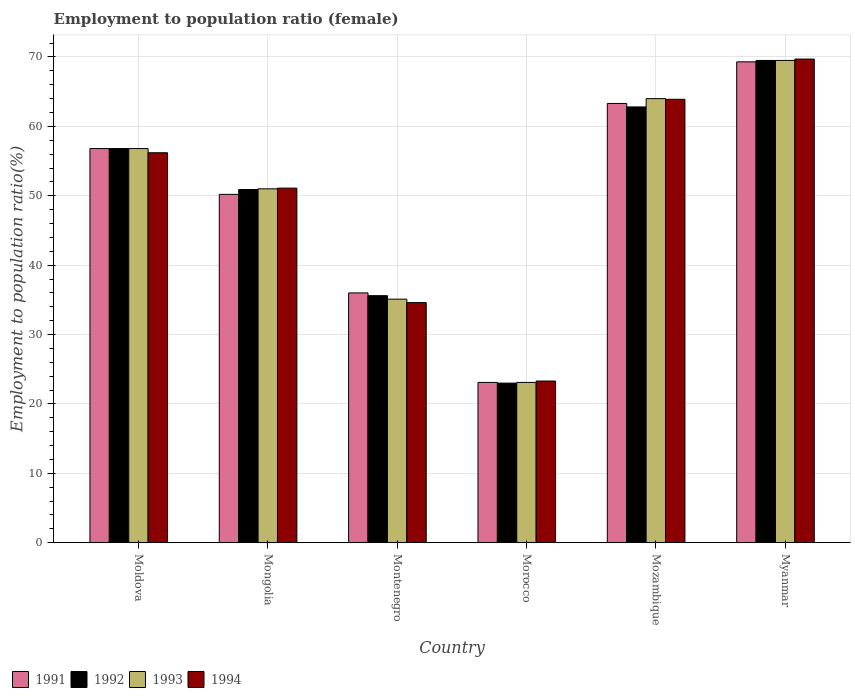How many different coloured bars are there?
Ensure brevity in your answer.  4. Are the number of bars per tick equal to the number of legend labels?
Your answer should be very brief. Yes. Are the number of bars on each tick of the X-axis equal?
Offer a terse response. Yes. What is the label of the 3rd group of bars from the left?
Ensure brevity in your answer.  Montenegro. What is the employment to population ratio in 1992 in Mongolia?
Ensure brevity in your answer.  50.9. Across all countries, what is the maximum employment to population ratio in 1993?
Provide a succinct answer. 69.5. Across all countries, what is the minimum employment to population ratio in 1991?
Make the answer very short. 23.1. In which country was the employment to population ratio in 1994 maximum?
Give a very brief answer. Myanmar. In which country was the employment to population ratio in 1993 minimum?
Ensure brevity in your answer.  Morocco. What is the total employment to population ratio in 1994 in the graph?
Your answer should be very brief. 298.8. What is the difference between the employment to population ratio in 1992 in Moldova and that in Morocco?
Your answer should be very brief. 33.8. What is the difference between the employment to population ratio in 1992 in Mozambique and the employment to population ratio in 1994 in Myanmar?
Offer a very short reply. -6.9. What is the average employment to population ratio in 1991 per country?
Give a very brief answer. 49.78. What is the ratio of the employment to population ratio in 1994 in Mozambique to that in Myanmar?
Provide a succinct answer. 0.92. Is the employment to population ratio in 1993 in Montenegro less than that in Morocco?
Your response must be concise. No. Is the difference between the employment to population ratio in 1994 in Moldova and Montenegro greater than the difference between the employment to population ratio in 1993 in Moldova and Montenegro?
Give a very brief answer. No. What is the difference between the highest and the second highest employment to population ratio in 1994?
Offer a very short reply. -13.5. What is the difference between the highest and the lowest employment to population ratio in 1992?
Your response must be concise. 46.5. In how many countries, is the employment to population ratio in 1993 greater than the average employment to population ratio in 1993 taken over all countries?
Offer a very short reply. 4. Is it the case that in every country, the sum of the employment to population ratio in 1991 and employment to population ratio in 1993 is greater than the sum of employment to population ratio in 1992 and employment to population ratio in 1994?
Offer a terse response. No. How are the legend labels stacked?
Make the answer very short. Horizontal. What is the title of the graph?
Your response must be concise. Employment to population ratio (female). What is the label or title of the X-axis?
Keep it short and to the point. Country. What is the Employment to population ratio(%) in 1991 in Moldova?
Make the answer very short. 56.8. What is the Employment to population ratio(%) in 1992 in Moldova?
Offer a very short reply. 56.8. What is the Employment to population ratio(%) in 1993 in Moldova?
Ensure brevity in your answer.  56.8. What is the Employment to population ratio(%) of 1994 in Moldova?
Provide a short and direct response. 56.2. What is the Employment to population ratio(%) in 1991 in Mongolia?
Your answer should be compact. 50.2. What is the Employment to population ratio(%) in 1992 in Mongolia?
Ensure brevity in your answer.  50.9. What is the Employment to population ratio(%) in 1994 in Mongolia?
Provide a succinct answer. 51.1. What is the Employment to population ratio(%) of 1992 in Montenegro?
Offer a terse response. 35.6. What is the Employment to population ratio(%) in 1993 in Montenegro?
Make the answer very short. 35.1. What is the Employment to population ratio(%) in 1994 in Montenegro?
Your response must be concise. 34.6. What is the Employment to population ratio(%) of 1991 in Morocco?
Make the answer very short. 23.1. What is the Employment to population ratio(%) in 1992 in Morocco?
Give a very brief answer. 23. What is the Employment to population ratio(%) in 1993 in Morocco?
Your response must be concise. 23.1. What is the Employment to population ratio(%) of 1994 in Morocco?
Offer a terse response. 23.3. What is the Employment to population ratio(%) in 1991 in Mozambique?
Provide a short and direct response. 63.3. What is the Employment to population ratio(%) in 1992 in Mozambique?
Keep it short and to the point. 62.8. What is the Employment to population ratio(%) of 1993 in Mozambique?
Give a very brief answer. 64. What is the Employment to population ratio(%) in 1994 in Mozambique?
Keep it short and to the point. 63.9. What is the Employment to population ratio(%) of 1991 in Myanmar?
Provide a succinct answer. 69.3. What is the Employment to population ratio(%) in 1992 in Myanmar?
Ensure brevity in your answer.  69.5. What is the Employment to population ratio(%) of 1993 in Myanmar?
Your answer should be compact. 69.5. What is the Employment to population ratio(%) of 1994 in Myanmar?
Your answer should be very brief. 69.7. Across all countries, what is the maximum Employment to population ratio(%) in 1991?
Provide a succinct answer. 69.3. Across all countries, what is the maximum Employment to population ratio(%) of 1992?
Ensure brevity in your answer.  69.5. Across all countries, what is the maximum Employment to population ratio(%) in 1993?
Provide a succinct answer. 69.5. Across all countries, what is the maximum Employment to population ratio(%) in 1994?
Make the answer very short. 69.7. Across all countries, what is the minimum Employment to population ratio(%) in 1991?
Ensure brevity in your answer.  23.1. Across all countries, what is the minimum Employment to population ratio(%) of 1992?
Offer a terse response. 23. Across all countries, what is the minimum Employment to population ratio(%) in 1993?
Give a very brief answer. 23.1. Across all countries, what is the minimum Employment to population ratio(%) of 1994?
Make the answer very short. 23.3. What is the total Employment to population ratio(%) of 1991 in the graph?
Your answer should be very brief. 298.7. What is the total Employment to population ratio(%) in 1992 in the graph?
Ensure brevity in your answer.  298.6. What is the total Employment to population ratio(%) in 1993 in the graph?
Ensure brevity in your answer.  299.5. What is the total Employment to population ratio(%) of 1994 in the graph?
Provide a succinct answer. 298.8. What is the difference between the Employment to population ratio(%) in 1991 in Moldova and that in Mongolia?
Ensure brevity in your answer.  6.6. What is the difference between the Employment to population ratio(%) in 1992 in Moldova and that in Mongolia?
Your answer should be very brief. 5.9. What is the difference between the Employment to population ratio(%) of 1993 in Moldova and that in Mongolia?
Provide a short and direct response. 5.8. What is the difference between the Employment to population ratio(%) of 1991 in Moldova and that in Montenegro?
Give a very brief answer. 20.8. What is the difference between the Employment to population ratio(%) of 1992 in Moldova and that in Montenegro?
Offer a very short reply. 21.2. What is the difference between the Employment to population ratio(%) in 1993 in Moldova and that in Montenegro?
Offer a terse response. 21.7. What is the difference between the Employment to population ratio(%) of 1994 in Moldova and that in Montenegro?
Keep it short and to the point. 21.6. What is the difference between the Employment to population ratio(%) in 1991 in Moldova and that in Morocco?
Provide a succinct answer. 33.7. What is the difference between the Employment to population ratio(%) of 1992 in Moldova and that in Morocco?
Ensure brevity in your answer.  33.8. What is the difference between the Employment to population ratio(%) in 1993 in Moldova and that in Morocco?
Keep it short and to the point. 33.7. What is the difference between the Employment to population ratio(%) in 1994 in Moldova and that in Morocco?
Offer a terse response. 32.9. What is the difference between the Employment to population ratio(%) in 1992 in Moldova and that in Mozambique?
Make the answer very short. -6. What is the difference between the Employment to population ratio(%) of 1993 in Moldova and that in Mozambique?
Offer a terse response. -7.2. What is the difference between the Employment to population ratio(%) in 1994 in Moldova and that in Mozambique?
Keep it short and to the point. -7.7. What is the difference between the Employment to population ratio(%) of 1993 in Moldova and that in Myanmar?
Provide a succinct answer. -12.7. What is the difference between the Employment to population ratio(%) of 1994 in Moldova and that in Myanmar?
Provide a succinct answer. -13.5. What is the difference between the Employment to population ratio(%) in 1991 in Mongolia and that in Montenegro?
Ensure brevity in your answer.  14.2. What is the difference between the Employment to population ratio(%) of 1991 in Mongolia and that in Morocco?
Provide a succinct answer. 27.1. What is the difference between the Employment to population ratio(%) of 1992 in Mongolia and that in Morocco?
Your answer should be very brief. 27.9. What is the difference between the Employment to population ratio(%) of 1993 in Mongolia and that in Morocco?
Provide a short and direct response. 27.9. What is the difference between the Employment to population ratio(%) of 1994 in Mongolia and that in Morocco?
Ensure brevity in your answer.  27.8. What is the difference between the Employment to population ratio(%) in 1991 in Mongolia and that in Mozambique?
Offer a terse response. -13.1. What is the difference between the Employment to population ratio(%) in 1992 in Mongolia and that in Mozambique?
Your answer should be compact. -11.9. What is the difference between the Employment to population ratio(%) of 1994 in Mongolia and that in Mozambique?
Make the answer very short. -12.8. What is the difference between the Employment to population ratio(%) of 1991 in Mongolia and that in Myanmar?
Offer a very short reply. -19.1. What is the difference between the Employment to population ratio(%) of 1992 in Mongolia and that in Myanmar?
Provide a succinct answer. -18.6. What is the difference between the Employment to population ratio(%) in 1993 in Mongolia and that in Myanmar?
Your answer should be very brief. -18.5. What is the difference between the Employment to population ratio(%) of 1994 in Mongolia and that in Myanmar?
Provide a succinct answer. -18.6. What is the difference between the Employment to population ratio(%) in 1993 in Montenegro and that in Morocco?
Give a very brief answer. 12. What is the difference between the Employment to population ratio(%) in 1991 in Montenegro and that in Mozambique?
Make the answer very short. -27.3. What is the difference between the Employment to population ratio(%) of 1992 in Montenegro and that in Mozambique?
Your answer should be very brief. -27.2. What is the difference between the Employment to population ratio(%) of 1993 in Montenegro and that in Mozambique?
Offer a terse response. -28.9. What is the difference between the Employment to population ratio(%) of 1994 in Montenegro and that in Mozambique?
Your response must be concise. -29.3. What is the difference between the Employment to population ratio(%) of 1991 in Montenegro and that in Myanmar?
Make the answer very short. -33.3. What is the difference between the Employment to population ratio(%) in 1992 in Montenegro and that in Myanmar?
Your answer should be compact. -33.9. What is the difference between the Employment to population ratio(%) in 1993 in Montenegro and that in Myanmar?
Make the answer very short. -34.4. What is the difference between the Employment to population ratio(%) of 1994 in Montenegro and that in Myanmar?
Offer a terse response. -35.1. What is the difference between the Employment to population ratio(%) in 1991 in Morocco and that in Mozambique?
Your answer should be very brief. -40.2. What is the difference between the Employment to population ratio(%) of 1992 in Morocco and that in Mozambique?
Your answer should be very brief. -39.8. What is the difference between the Employment to population ratio(%) of 1993 in Morocco and that in Mozambique?
Keep it short and to the point. -40.9. What is the difference between the Employment to population ratio(%) of 1994 in Morocco and that in Mozambique?
Give a very brief answer. -40.6. What is the difference between the Employment to population ratio(%) in 1991 in Morocco and that in Myanmar?
Keep it short and to the point. -46.2. What is the difference between the Employment to population ratio(%) in 1992 in Morocco and that in Myanmar?
Offer a terse response. -46.5. What is the difference between the Employment to population ratio(%) in 1993 in Morocco and that in Myanmar?
Your response must be concise. -46.4. What is the difference between the Employment to population ratio(%) of 1994 in Morocco and that in Myanmar?
Provide a short and direct response. -46.4. What is the difference between the Employment to population ratio(%) in 1991 in Mozambique and that in Myanmar?
Your response must be concise. -6. What is the difference between the Employment to population ratio(%) in 1992 in Mozambique and that in Myanmar?
Keep it short and to the point. -6.7. What is the difference between the Employment to population ratio(%) in 1991 in Moldova and the Employment to population ratio(%) in 1992 in Mongolia?
Offer a terse response. 5.9. What is the difference between the Employment to population ratio(%) of 1991 in Moldova and the Employment to population ratio(%) of 1994 in Mongolia?
Offer a very short reply. 5.7. What is the difference between the Employment to population ratio(%) of 1993 in Moldova and the Employment to population ratio(%) of 1994 in Mongolia?
Give a very brief answer. 5.7. What is the difference between the Employment to population ratio(%) of 1991 in Moldova and the Employment to population ratio(%) of 1992 in Montenegro?
Offer a very short reply. 21.2. What is the difference between the Employment to population ratio(%) in 1991 in Moldova and the Employment to population ratio(%) in 1993 in Montenegro?
Offer a terse response. 21.7. What is the difference between the Employment to population ratio(%) in 1992 in Moldova and the Employment to population ratio(%) in 1993 in Montenegro?
Make the answer very short. 21.7. What is the difference between the Employment to population ratio(%) in 1992 in Moldova and the Employment to population ratio(%) in 1994 in Montenegro?
Provide a short and direct response. 22.2. What is the difference between the Employment to population ratio(%) of 1993 in Moldova and the Employment to population ratio(%) of 1994 in Montenegro?
Your response must be concise. 22.2. What is the difference between the Employment to population ratio(%) in 1991 in Moldova and the Employment to population ratio(%) in 1992 in Morocco?
Offer a very short reply. 33.8. What is the difference between the Employment to population ratio(%) in 1991 in Moldova and the Employment to population ratio(%) in 1993 in Morocco?
Your response must be concise. 33.7. What is the difference between the Employment to population ratio(%) in 1991 in Moldova and the Employment to population ratio(%) in 1994 in Morocco?
Give a very brief answer. 33.5. What is the difference between the Employment to population ratio(%) in 1992 in Moldova and the Employment to population ratio(%) in 1993 in Morocco?
Give a very brief answer. 33.7. What is the difference between the Employment to population ratio(%) in 1992 in Moldova and the Employment to population ratio(%) in 1994 in Morocco?
Keep it short and to the point. 33.5. What is the difference between the Employment to population ratio(%) of 1993 in Moldova and the Employment to population ratio(%) of 1994 in Morocco?
Provide a succinct answer. 33.5. What is the difference between the Employment to population ratio(%) in 1991 in Moldova and the Employment to population ratio(%) in 1993 in Mozambique?
Your answer should be very brief. -7.2. What is the difference between the Employment to population ratio(%) in 1991 in Moldova and the Employment to population ratio(%) in 1994 in Mozambique?
Offer a terse response. -7.1. What is the difference between the Employment to population ratio(%) in 1993 in Moldova and the Employment to population ratio(%) in 1994 in Mozambique?
Provide a short and direct response. -7.1. What is the difference between the Employment to population ratio(%) of 1991 in Moldova and the Employment to population ratio(%) of 1994 in Myanmar?
Your response must be concise. -12.9. What is the difference between the Employment to population ratio(%) of 1993 in Moldova and the Employment to population ratio(%) of 1994 in Myanmar?
Keep it short and to the point. -12.9. What is the difference between the Employment to population ratio(%) in 1991 in Mongolia and the Employment to population ratio(%) in 1992 in Montenegro?
Provide a succinct answer. 14.6. What is the difference between the Employment to population ratio(%) in 1991 in Mongolia and the Employment to population ratio(%) in 1993 in Montenegro?
Your answer should be compact. 15.1. What is the difference between the Employment to population ratio(%) of 1992 in Mongolia and the Employment to population ratio(%) of 1994 in Montenegro?
Give a very brief answer. 16.3. What is the difference between the Employment to population ratio(%) in 1993 in Mongolia and the Employment to population ratio(%) in 1994 in Montenegro?
Provide a short and direct response. 16.4. What is the difference between the Employment to population ratio(%) of 1991 in Mongolia and the Employment to population ratio(%) of 1992 in Morocco?
Your answer should be compact. 27.2. What is the difference between the Employment to population ratio(%) in 1991 in Mongolia and the Employment to population ratio(%) in 1993 in Morocco?
Provide a succinct answer. 27.1. What is the difference between the Employment to population ratio(%) in 1991 in Mongolia and the Employment to population ratio(%) in 1994 in Morocco?
Your response must be concise. 26.9. What is the difference between the Employment to population ratio(%) in 1992 in Mongolia and the Employment to population ratio(%) in 1993 in Morocco?
Keep it short and to the point. 27.8. What is the difference between the Employment to population ratio(%) in 1992 in Mongolia and the Employment to population ratio(%) in 1994 in Morocco?
Offer a very short reply. 27.6. What is the difference between the Employment to population ratio(%) in 1993 in Mongolia and the Employment to population ratio(%) in 1994 in Morocco?
Offer a very short reply. 27.7. What is the difference between the Employment to population ratio(%) in 1991 in Mongolia and the Employment to population ratio(%) in 1993 in Mozambique?
Ensure brevity in your answer.  -13.8. What is the difference between the Employment to population ratio(%) of 1991 in Mongolia and the Employment to population ratio(%) of 1994 in Mozambique?
Provide a succinct answer. -13.7. What is the difference between the Employment to population ratio(%) in 1992 in Mongolia and the Employment to population ratio(%) in 1993 in Mozambique?
Your answer should be compact. -13.1. What is the difference between the Employment to population ratio(%) of 1992 in Mongolia and the Employment to population ratio(%) of 1994 in Mozambique?
Your answer should be compact. -13. What is the difference between the Employment to population ratio(%) of 1993 in Mongolia and the Employment to population ratio(%) of 1994 in Mozambique?
Keep it short and to the point. -12.9. What is the difference between the Employment to population ratio(%) of 1991 in Mongolia and the Employment to population ratio(%) of 1992 in Myanmar?
Offer a very short reply. -19.3. What is the difference between the Employment to population ratio(%) of 1991 in Mongolia and the Employment to population ratio(%) of 1993 in Myanmar?
Offer a very short reply. -19.3. What is the difference between the Employment to population ratio(%) in 1991 in Mongolia and the Employment to population ratio(%) in 1994 in Myanmar?
Offer a very short reply. -19.5. What is the difference between the Employment to population ratio(%) in 1992 in Mongolia and the Employment to population ratio(%) in 1993 in Myanmar?
Offer a very short reply. -18.6. What is the difference between the Employment to population ratio(%) in 1992 in Mongolia and the Employment to population ratio(%) in 1994 in Myanmar?
Your response must be concise. -18.8. What is the difference between the Employment to population ratio(%) in 1993 in Mongolia and the Employment to population ratio(%) in 1994 in Myanmar?
Give a very brief answer. -18.7. What is the difference between the Employment to population ratio(%) of 1991 in Montenegro and the Employment to population ratio(%) of 1993 in Morocco?
Ensure brevity in your answer.  12.9. What is the difference between the Employment to population ratio(%) in 1991 in Montenegro and the Employment to population ratio(%) in 1994 in Morocco?
Provide a short and direct response. 12.7. What is the difference between the Employment to population ratio(%) of 1993 in Montenegro and the Employment to population ratio(%) of 1994 in Morocco?
Your answer should be compact. 11.8. What is the difference between the Employment to population ratio(%) in 1991 in Montenegro and the Employment to population ratio(%) in 1992 in Mozambique?
Offer a terse response. -26.8. What is the difference between the Employment to population ratio(%) of 1991 in Montenegro and the Employment to population ratio(%) of 1994 in Mozambique?
Your answer should be compact. -27.9. What is the difference between the Employment to population ratio(%) of 1992 in Montenegro and the Employment to population ratio(%) of 1993 in Mozambique?
Provide a succinct answer. -28.4. What is the difference between the Employment to population ratio(%) in 1992 in Montenegro and the Employment to population ratio(%) in 1994 in Mozambique?
Your answer should be very brief. -28.3. What is the difference between the Employment to population ratio(%) of 1993 in Montenegro and the Employment to population ratio(%) of 1994 in Mozambique?
Your response must be concise. -28.8. What is the difference between the Employment to population ratio(%) of 1991 in Montenegro and the Employment to population ratio(%) of 1992 in Myanmar?
Give a very brief answer. -33.5. What is the difference between the Employment to population ratio(%) of 1991 in Montenegro and the Employment to population ratio(%) of 1993 in Myanmar?
Provide a succinct answer. -33.5. What is the difference between the Employment to population ratio(%) of 1991 in Montenegro and the Employment to population ratio(%) of 1994 in Myanmar?
Offer a terse response. -33.7. What is the difference between the Employment to population ratio(%) of 1992 in Montenegro and the Employment to population ratio(%) of 1993 in Myanmar?
Your answer should be very brief. -33.9. What is the difference between the Employment to population ratio(%) in 1992 in Montenegro and the Employment to population ratio(%) in 1994 in Myanmar?
Make the answer very short. -34.1. What is the difference between the Employment to population ratio(%) of 1993 in Montenegro and the Employment to population ratio(%) of 1994 in Myanmar?
Provide a short and direct response. -34.6. What is the difference between the Employment to population ratio(%) in 1991 in Morocco and the Employment to population ratio(%) in 1992 in Mozambique?
Your response must be concise. -39.7. What is the difference between the Employment to population ratio(%) in 1991 in Morocco and the Employment to population ratio(%) in 1993 in Mozambique?
Ensure brevity in your answer.  -40.9. What is the difference between the Employment to population ratio(%) of 1991 in Morocco and the Employment to population ratio(%) of 1994 in Mozambique?
Your answer should be very brief. -40.8. What is the difference between the Employment to population ratio(%) of 1992 in Morocco and the Employment to population ratio(%) of 1993 in Mozambique?
Offer a very short reply. -41. What is the difference between the Employment to population ratio(%) in 1992 in Morocco and the Employment to population ratio(%) in 1994 in Mozambique?
Keep it short and to the point. -40.9. What is the difference between the Employment to population ratio(%) in 1993 in Morocco and the Employment to population ratio(%) in 1994 in Mozambique?
Ensure brevity in your answer.  -40.8. What is the difference between the Employment to population ratio(%) of 1991 in Morocco and the Employment to population ratio(%) of 1992 in Myanmar?
Your answer should be compact. -46.4. What is the difference between the Employment to population ratio(%) of 1991 in Morocco and the Employment to population ratio(%) of 1993 in Myanmar?
Your answer should be compact. -46.4. What is the difference between the Employment to population ratio(%) of 1991 in Morocco and the Employment to population ratio(%) of 1994 in Myanmar?
Provide a short and direct response. -46.6. What is the difference between the Employment to population ratio(%) of 1992 in Morocco and the Employment to population ratio(%) of 1993 in Myanmar?
Keep it short and to the point. -46.5. What is the difference between the Employment to population ratio(%) of 1992 in Morocco and the Employment to population ratio(%) of 1994 in Myanmar?
Your answer should be very brief. -46.7. What is the difference between the Employment to population ratio(%) in 1993 in Morocco and the Employment to population ratio(%) in 1994 in Myanmar?
Offer a terse response. -46.6. What is the difference between the Employment to population ratio(%) in 1991 in Mozambique and the Employment to population ratio(%) in 1992 in Myanmar?
Your answer should be compact. -6.2. What is the difference between the Employment to population ratio(%) of 1991 in Mozambique and the Employment to population ratio(%) of 1994 in Myanmar?
Offer a very short reply. -6.4. What is the difference between the Employment to population ratio(%) of 1992 in Mozambique and the Employment to population ratio(%) of 1993 in Myanmar?
Offer a terse response. -6.7. What is the difference between the Employment to population ratio(%) of 1992 in Mozambique and the Employment to population ratio(%) of 1994 in Myanmar?
Keep it short and to the point. -6.9. What is the average Employment to population ratio(%) in 1991 per country?
Ensure brevity in your answer.  49.78. What is the average Employment to population ratio(%) in 1992 per country?
Your answer should be very brief. 49.77. What is the average Employment to population ratio(%) of 1993 per country?
Provide a succinct answer. 49.92. What is the average Employment to population ratio(%) of 1994 per country?
Provide a short and direct response. 49.8. What is the difference between the Employment to population ratio(%) of 1991 and Employment to population ratio(%) of 1994 in Moldova?
Provide a short and direct response. 0.6. What is the difference between the Employment to population ratio(%) of 1992 and Employment to population ratio(%) of 1994 in Moldova?
Provide a short and direct response. 0.6. What is the difference between the Employment to population ratio(%) of 1991 and Employment to population ratio(%) of 1992 in Mongolia?
Offer a terse response. -0.7. What is the difference between the Employment to population ratio(%) of 1991 and Employment to population ratio(%) of 1994 in Mongolia?
Make the answer very short. -0.9. What is the difference between the Employment to population ratio(%) in 1992 and Employment to population ratio(%) in 1993 in Mongolia?
Ensure brevity in your answer.  -0.1. What is the difference between the Employment to population ratio(%) in 1993 and Employment to population ratio(%) in 1994 in Mongolia?
Provide a succinct answer. -0.1. What is the difference between the Employment to population ratio(%) in 1991 and Employment to population ratio(%) in 1992 in Montenegro?
Your response must be concise. 0.4. What is the difference between the Employment to population ratio(%) in 1991 and Employment to population ratio(%) in 1993 in Montenegro?
Give a very brief answer. 0.9. What is the difference between the Employment to population ratio(%) in 1991 and Employment to population ratio(%) in 1994 in Montenegro?
Your response must be concise. 1.4. What is the difference between the Employment to population ratio(%) of 1992 and Employment to population ratio(%) of 1993 in Montenegro?
Your response must be concise. 0.5. What is the difference between the Employment to population ratio(%) in 1991 and Employment to population ratio(%) in 1992 in Morocco?
Offer a very short reply. 0.1. What is the difference between the Employment to population ratio(%) in 1991 and Employment to population ratio(%) in 1993 in Morocco?
Make the answer very short. 0. What is the difference between the Employment to population ratio(%) in 1991 and Employment to population ratio(%) in 1994 in Morocco?
Ensure brevity in your answer.  -0.2. What is the difference between the Employment to population ratio(%) in 1992 and Employment to population ratio(%) in 1993 in Morocco?
Offer a very short reply. -0.1. What is the difference between the Employment to population ratio(%) in 1992 and Employment to population ratio(%) in 1994 in Morocco?
Give a very brief answer. -0.3. What is the difference between the Employment to population ratio(%) in 1991 and Employment to population ratio(%) in 1992 in Mozambique?
Your answer should be very brief. 0.5. What is the difference between the Employment to population ratio(%) of 1991 and Employment to population ratio(%) of 1993 in Mozambique?
Offer a very short reply. -0.7. What is the difference between the Employment to population ratio(%) in 1992 and Employment to population ratio(%) in 1993 in Mozambique?
Your response must be concise. -1.2. What is the difference between the Employment to population ratio(%) of 1993 and Employment to population ratio(%) of 1994 in Mozambique?
Ensure brevity in your answer.  0.1. What is the difference between the Employment to population ratio(%) of 1991 and Employment to population ratio(%) of 1992 in Myanmar?
Your answer should be compact. -0.2. What is the difference between the Employment to population ratio(%) of 1991 and Employment to population ratio(%) of 1993 in Myanmar?
Give a very brief answer. -0.2. What is the difference between the Employment to population ratio(%) in 1992 and Employment to population ratio(%) in 1993 in Myanmar?
Give a very brief answer. 0. What is the ratio of the Employment to population ratio(%) of 1991 in Moldova to that in Mongolia?
Offer a terse response. 1.13. What is the ratio of the Employment to population ratio(%) of 1992 in Moldova to that in Mongolia?
Ensure brevity in your answer.  1.12. What is the ratio of the Employment to population ratio(%) of 1993 in Moldova to that in Mongolia?
Provide a short and direct response. 1.11. What is the ratio of the Employment to population ratio(%) of 1994 in Moldova to that in Mongolia?
Make the answer very short. 1.1. What is the ratio of the Employment to population ratio(%) in 1991 in Moldova to that in Montenegro?
Your response must be concise. 1.58. What is the ratio of the Employment to population ratio(%) of 1992 in Moldova to that in Montenegro?
Your answer should be very brief. 1.6. What is the ratio of the Employment to population ratio(%) of 1993 in Moldova to that in Montenegro?
Your response must be concise. 1.62. What is the ratio of the Employment to population ratio(%) of 1994 in Moldova to that in Montenegro?
Your answer should be compact. 1.62. What is the ratio of the Employment to population ratio(%) in 1991 in Moldova to that in Morocco?
Offer a terse response. 2.46. What is the ratio of the Employment to population ratio(%) of 1992 in Moldova to that in Morocco?
Provide a short and direct response. 2.47. What is the ratio of the Employment to population ratio(%) in 1993 in Moldova to that in Morocco?
Provide a succinct answer. 2.46. What is the ratio of the Employment to population ratio(%) in 1994 in Moldova to that in Morocco?
Your answer should be compact. 2.41. What is the ratio of the Employment to population ratio(%) in 1991 in Moldova to that in Mozambique?
Your response must be concise. 0.9. What is the ratio of the Employment to population ratio(%) of 1992 in Moldova to that in Mozambique?
Provide a succinct answer. 0.9. What is the ratio of the Employment to population ratio(%) in 1993 in Moldova to that in Mozambique?
Offer a terse response. 0.89. What is the ratio of the Employment to population ratio(%) in 1994 in Moldova to that in Mozambique?
Ensure brevity in your answer.  0.88. What is the ratio of the Employment to population ratio(%) in 1991 in Moldova to that in Myanmar?
Offer a very short reply. 0.82. What is the ratio of the Employment to population ratio(%) of 1992 in Moldova to that in Myanmar?
Provide a short and direct response. 0.82. What is the ratio of the Employment to population ratio(%) in 1993 in Moldova to that in Myanmar?
Make the answer very short. 0.82. What is the ratio of the Employment to population ratio(%) in 1994 in Moldova to that in Myanmar?
Provide a short and direct response. 0.81. What is the ratio of the Employment to population ratio(%) in 1991 in Mongolia to that in Montenegro?
Make the answer very short. 1.39. What is the ratio of the Employment to population ratio(%) of 1992 in Mongolia to that in Montenegro?
Make the answer very short. 1.43. What is the ratio of the Employment to population ratio(%) of 1993 in Mongolia to that in Montenegro?
Your answer should be compact. 1.45. What is the ratio of the Employment to population ratio(%) in 1994 in Mongolia to that in Montenegro?
Provide a short and direct response. 1.48. What is the ratio of the Employment to population ratio(%) of 1991 in Mongolia to that in Morocco?
Offer a terse response. 2.17. What is the ratio of the Employment to population ratio(%) in 1992 in Mongolia to that in Morocco?
Offer a very short reply. 2.21. What is the ratio of the Employment to population ratio(%) in 1993 in Mongolia to that in Morocco?
Give a very brief answer. 2.21. What is the ratio of the Employment to population ratio(%) in 1994 in Mongolia to that in Morocco?
Keep it short and to the point. 2.19. What is the ratio of the Employment to population ratio(%) of 1991 in Mongolia to that in Mozambique?
Ensure brevity in your answer.  0.79. What is the ratio of the Employment to population ratio(%) in 1992 in Mongolia to that in Mozambique?
Ensure brevity in your answer.  0.81. What is the ratio of the Employment to population ratio(%) of 1993 in Mongolia to that in Mozambique?
Your response must be concise. 0.8. What is the ratio of the Employment to population ratio(%) in 1994 in Mongolia to that in Mozambique?
Make the answer very short. 0.8. What is the ratio of the Employment to population ratio(%) of 1991 in Mongolia to that in Myanmar?
Make the answer very short. 0.72. What is the ratio of the Employment to population ratio(%) of 1992 in Mongolia to that in Myanmar?
Provide a succinct answer. 0.73. What is the ratio of the Employment to population ratio(%) in 1993 in Mongolia to that in Myanmar?
Offer a very short reply. 0.73. What is the ratio of the Employment to population ratio(%) of 1994 in Mongolia to that in Myanmar?
Provide a short and direct response. 0.73. What is the ratio of the Employment to population ratio(%) in 1991 in Montenegro to that in Morocco?
Keep it short and to the point. 1.56. What is the ratio of the Employment to population ratio(%) of 1992 in Montenegro to that in Morocco?
Give a very brief answer. 1.55. What is the ratio of the Employment to population ratio(%) in 1993 in Montenegro to that in Morocco?
Give a very brief answer. 1.52. What is the ratio of the Employment to population ratio(%) of 1994 in Montenegro to that in Morocco?
Your answer should be very brief. 1.49. What is the ratio of the Employment to population ratio(%) of 1991 in Montenegro to that in Mozambique?
Offer a very short reply. 0.57. What is the ratio of the Employment to population ratio(%) of 1992 in Montenegro to that in Mozambique?
Offer a terse response. 0.57. What is the ratio of the Employment to population ratio(%) of 1993 in Montenegro to that in Mozambique?
Provide a succinct answer. 0.55. What is the ratio of the Employment to population ratio(%) in 1994 in Montenegro to that in Mozambique?
Your answer should be compact. 0.54. What is the ratio of the Employment to population ratio(%) of 1991 in Montenegro to that in Myanmar?
Your response must be concise. 0.52. What is the ratio of the Employment to population ratio(%) in 1992 in Montenegro to that in Myanmar?
Ensure brevity in your answer.  0.51. What is the ratio of the Employment to population ratio(%) in 1993 in Montenegro to that in Myanmar?
Keep it short and to the point. 0.51. What is the ratio of the Employment to population ratio(%) of 1994 in Montenegro to that in Myanmar?
Give a very brief answer. 0.5. What is the ratio of the Employment to population ratio(%) of 1991 in Morocco to that in Mozambique?
Your answer should be compact. 0.36. What is the ratio of the Employment to population ratio(%) of 1992 in Morocco to that in Mozambique?
Make the answer very short. 0.37. What is the ratio of the Employment to population ratio(%) in 1993 in Morocco to that in Mozambique?
Provide a succinct answer. 0.36. What is the ratio of the Employment to population ratio(%) of 1994 in Morocco to that in Mozambique?
Your answer should be compact. 0.36. What is the ratio of the Employment to population ratio(%) in 1992 in Morocco to that in Myanmar?
Your answer should be very brief. 0.33. What is the ratio of the Employment to population ratio(%) of 1993 in Morocco to that in Myanmar?
Your answer should be compact. 0.33. What is the ratio of the Employment to population ratio(%) of 1994 in Morocco to that in Myanmar?
Give a very brief answer. 0.33. What is the ratio of the Employment to population ratio(%) of 1991 in Mozambique to that in Myanmar?
Ensure brevity in your answer.  0.91. What is the ratio of the Employment to population ratio(%) of 1992 in Mozambique to that in Myanmar?
Your response must be concise. 0.9. What is the ratio of the Employment to population ratio(%) in 1993 in Mozambique to that in Myanmar?
Ensure brevity in your answer.  0.92. What is the ratio of the Employment to population ratio(%) in 1994 in Mozambique to that in Myanmar?
Provide a short and direct response. 0.92. What is the difference between the highest and the second highest Employment to population ratio(%) of 1993?
Give a very brief answer. 5.5. What is the difference between the highest and the lowest Employment to population ratio(%) of 1991?
Provide a short and direct response. 46.2. What is the difference between the highest and the lowest Employment to population ratio(%) in 1992?
Provide a short and direct response. 46.5. What is the difference between the highest and the lowest Employment to population ratio(%) of 1993?
Your answer should be compact. 46.4. What is the difference between the highest and the lowest Employment to population ratio(%) in 1994?
Provide a short and direct response. 46.4. 